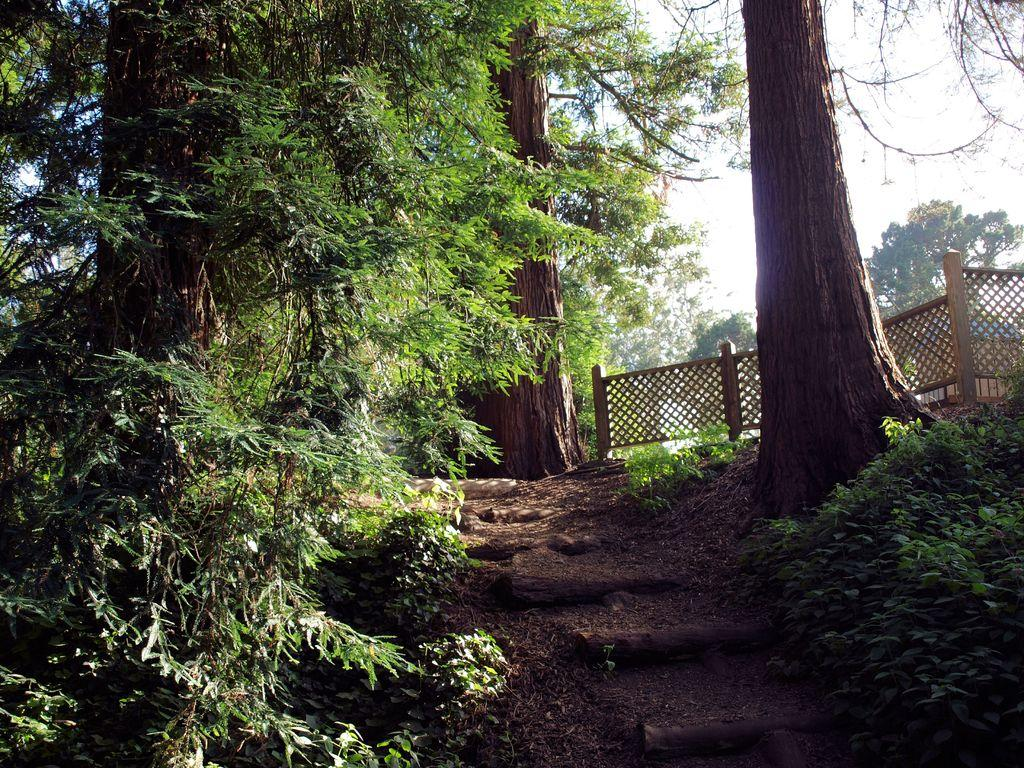What type of vegetation can be seen in the image? There are trees and plants in the image. What is the purpose of the fencing in the image? The purpose of the fencing in the image is not specified, but it could be for enclosing an area or providing a boundary. What type of teaching is happening in the image? There is no teaching happening in the image; it only features trees, plants, and fencing. 